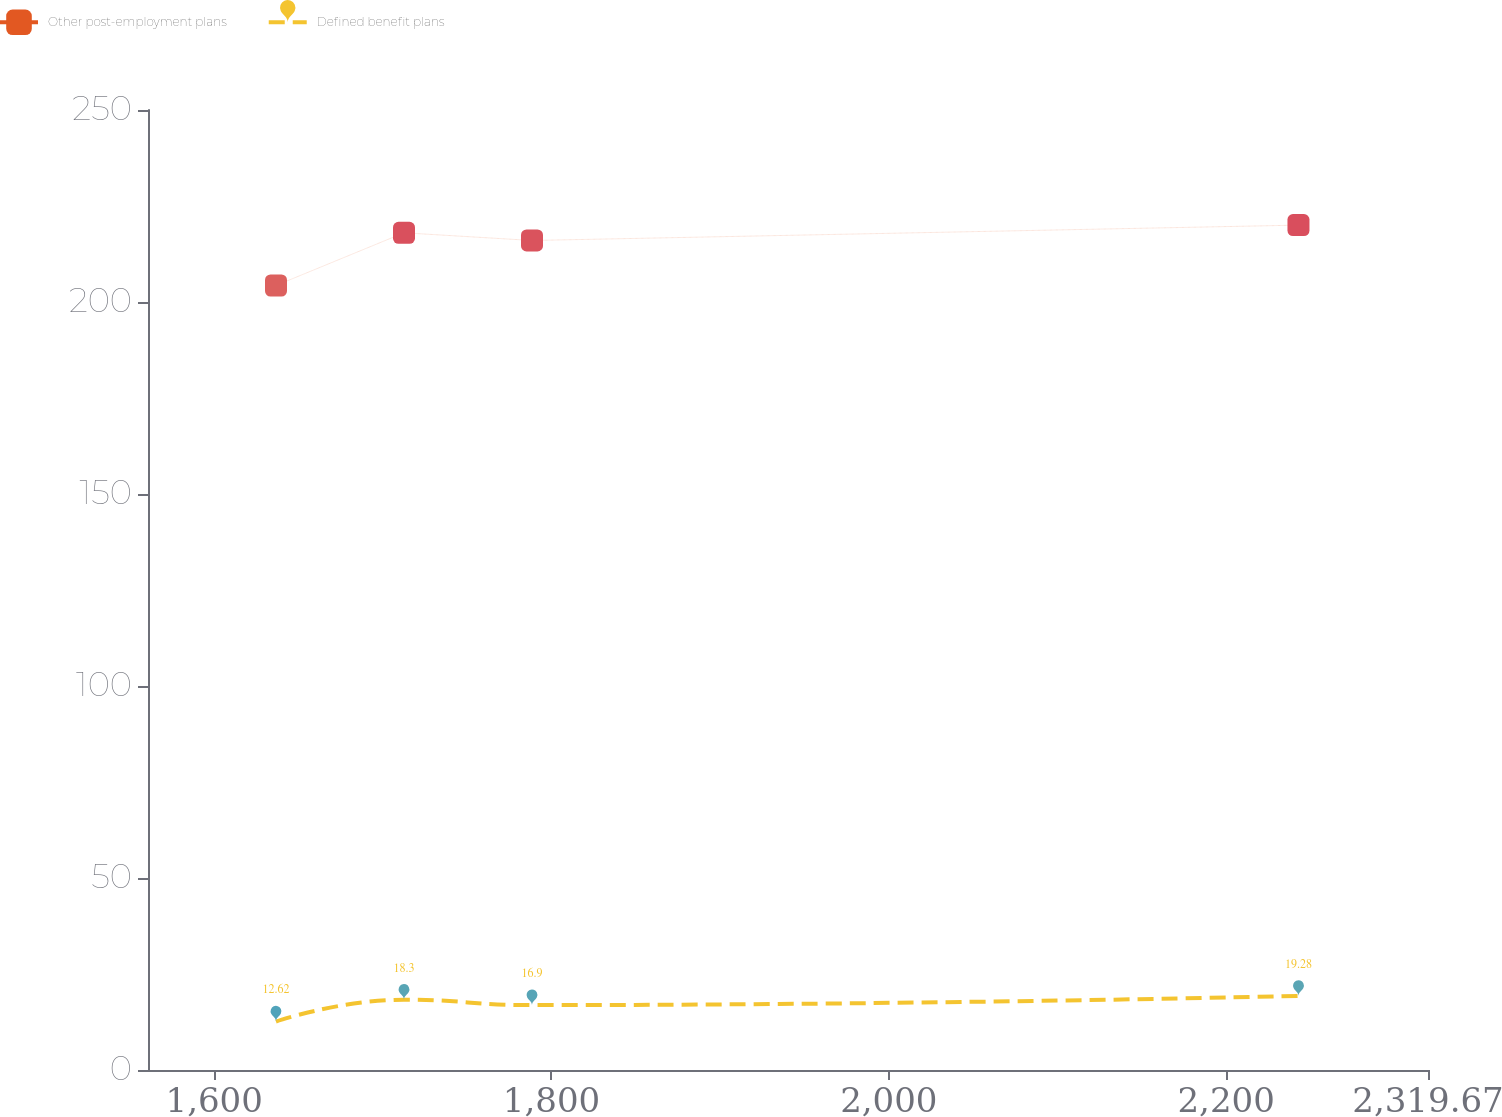Convert chart to OTSL. <chart><loc_0><loc_0><loc_500><loc_500><line_chart><ecel><fcel>Other post-employment plans<fcel>Defined benefit plans<nl><fcel>1636.66<fcel>204.3<fcel>12.62<nl><fcel>1712.55<fcel>218.02<fcel>18.3<nl><fcel>1788.44<fcel>216.02<fcel>16.9<nl><fcel>2242.87<fcel>220.02<fcel>19.28<nl><fcel>2395.56<fcel>199.95<fcel>22.37<nl></chart> 